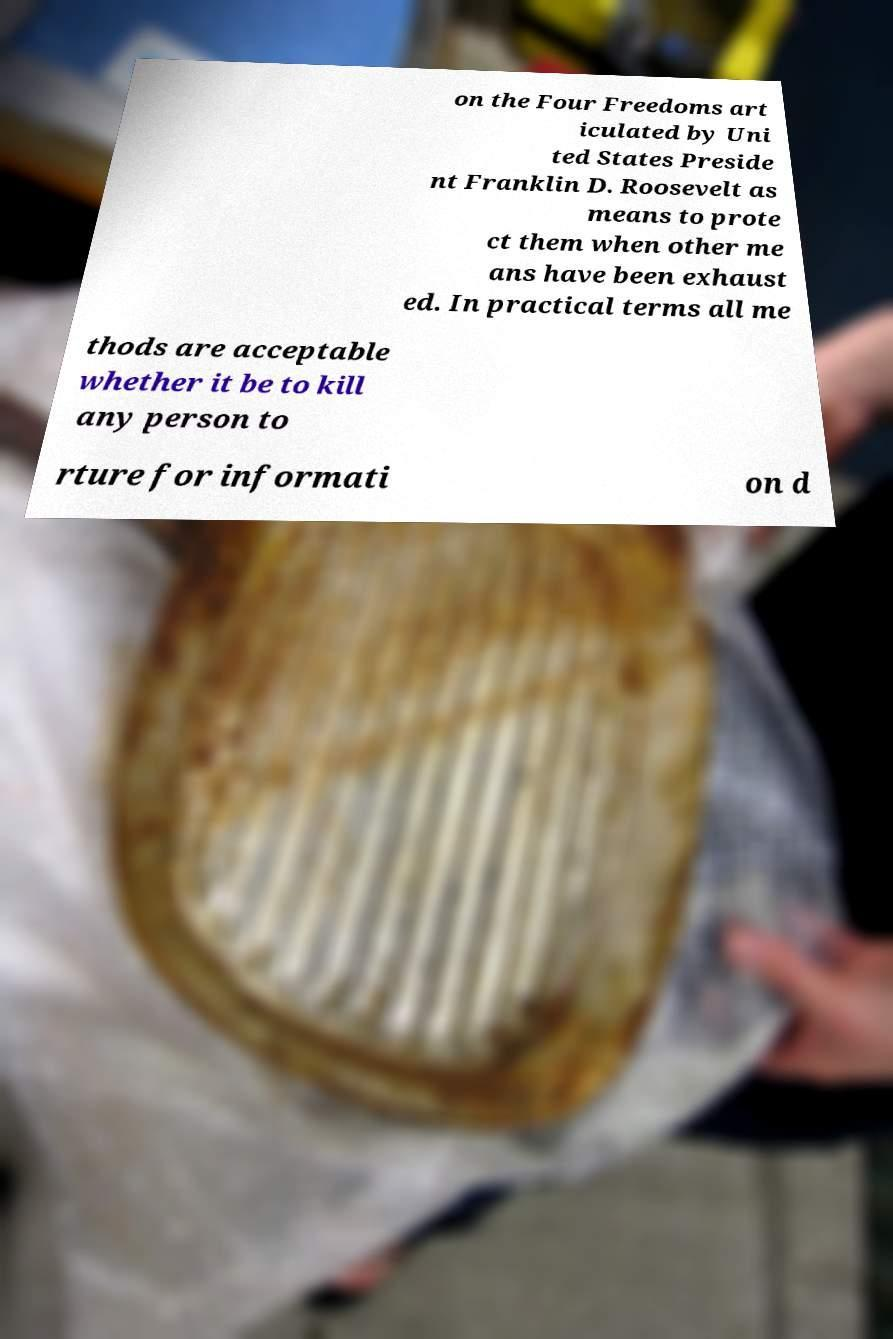Can you read and provide the text displayed in the image?This photo seems to have some interesting text. Can you extract and type it out for me? on the Four Freedoms art iculated by Uni ted States Preside nt Franklin D. Roosevelt as means to prote ct them when other me ans have been exhaust ed. In practical terms all me thods are acceptable whether it be to kill any person to rture for informati on d 